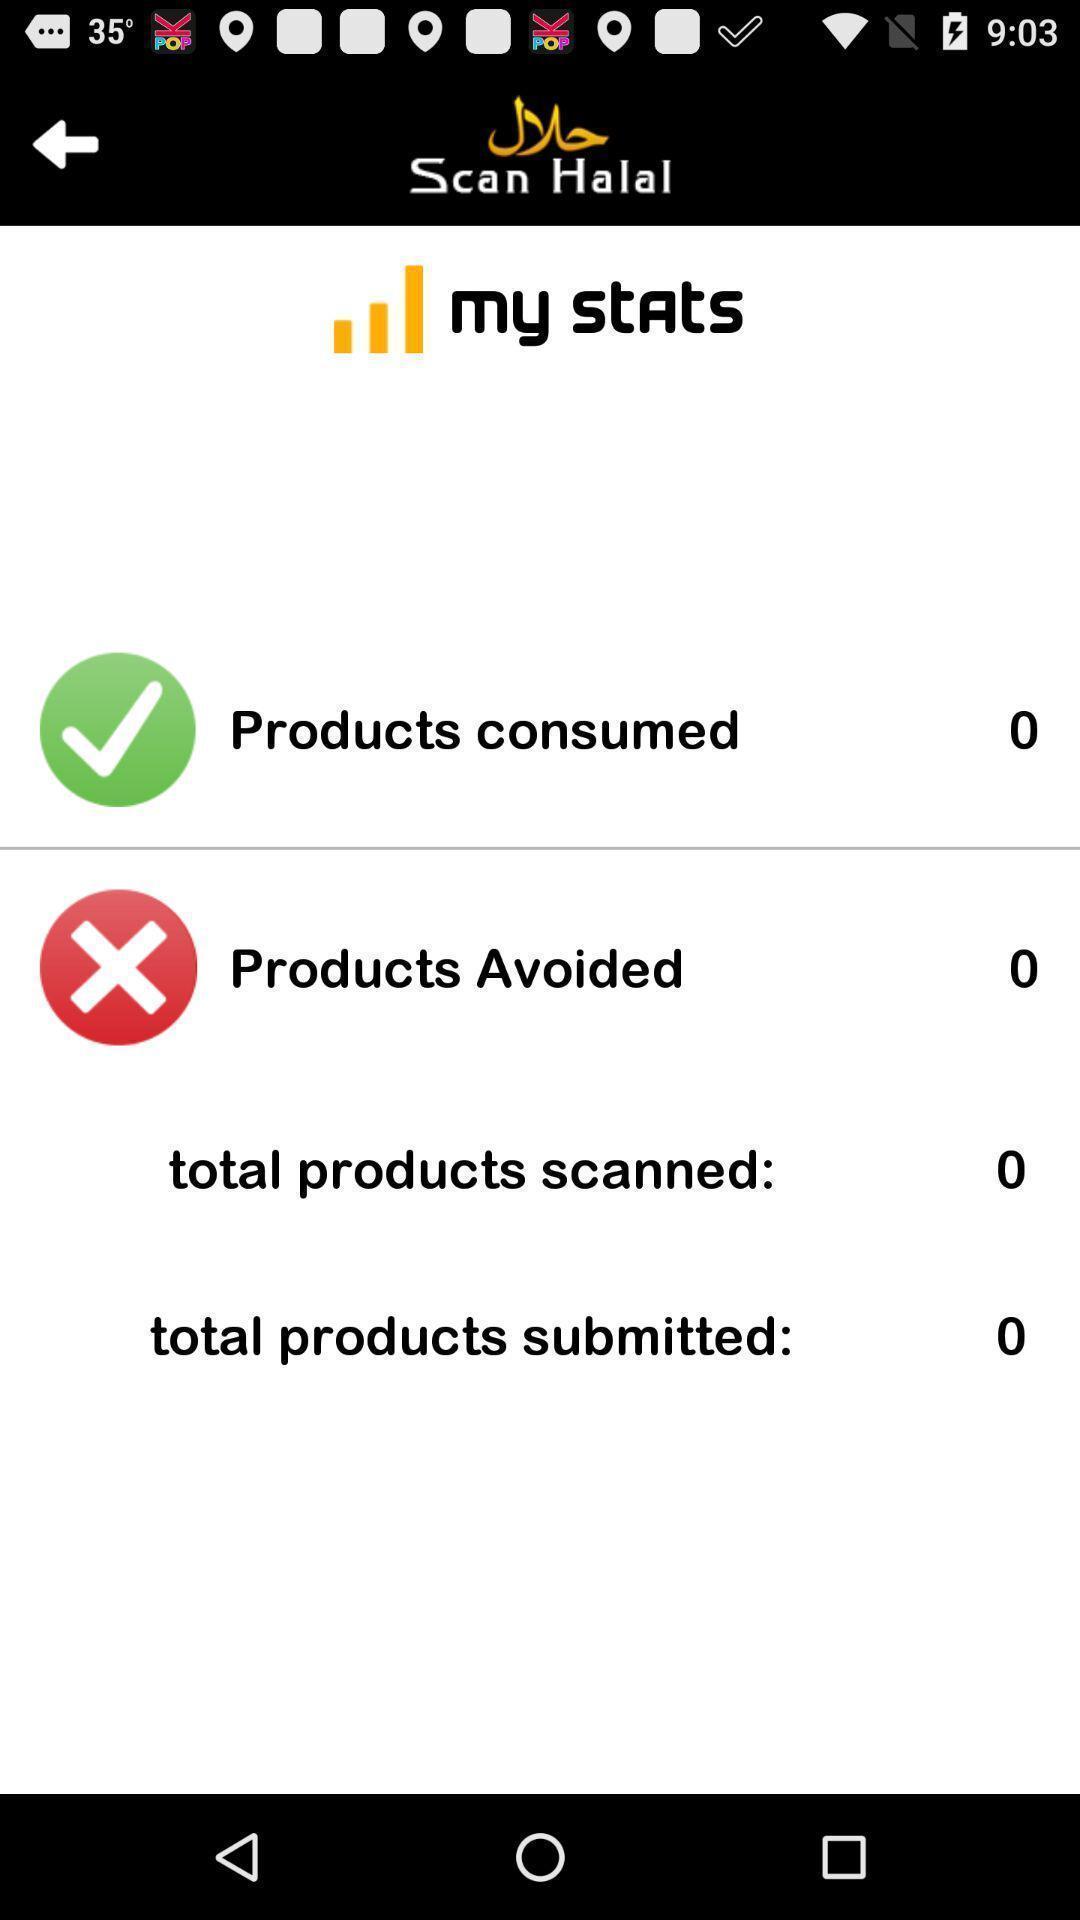What details can you identify in this image? Stats page. 